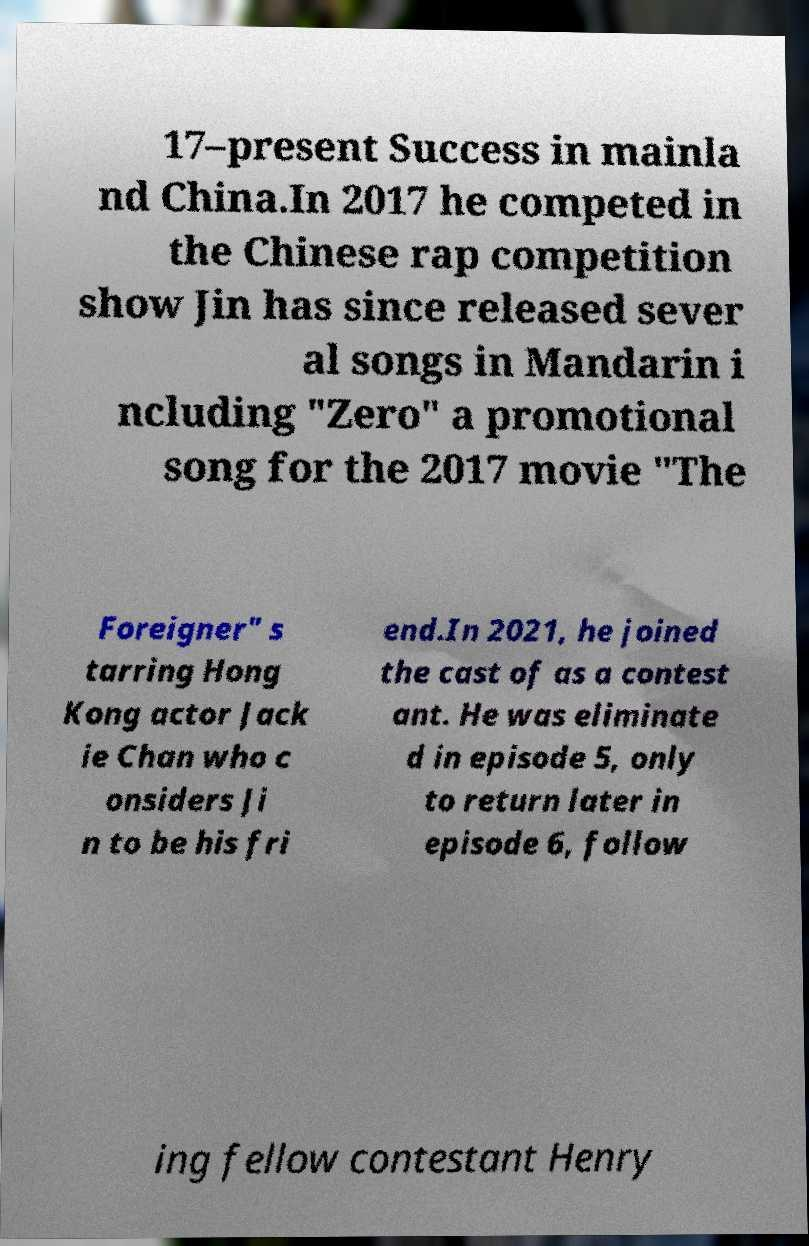There's text embedded in this image that I need extracted. Can you transcribe it verbatim? 17–present Success in mainla nd China.In 2017 he competed in the Chinese rap competition show Jin has since released sever al songs in Mandarin i ncluding "Zero" a promotional song for the 2017 movie "The Foreigner" s tarring Hong Kong actor Jack ie Chan who c onsiders Ji n to be his fri end.In 2021, he joined the cast of as a contest ant. He was eliminate d in episode 5, only to return later in episode 6, follow ing fellow contestant Henry 